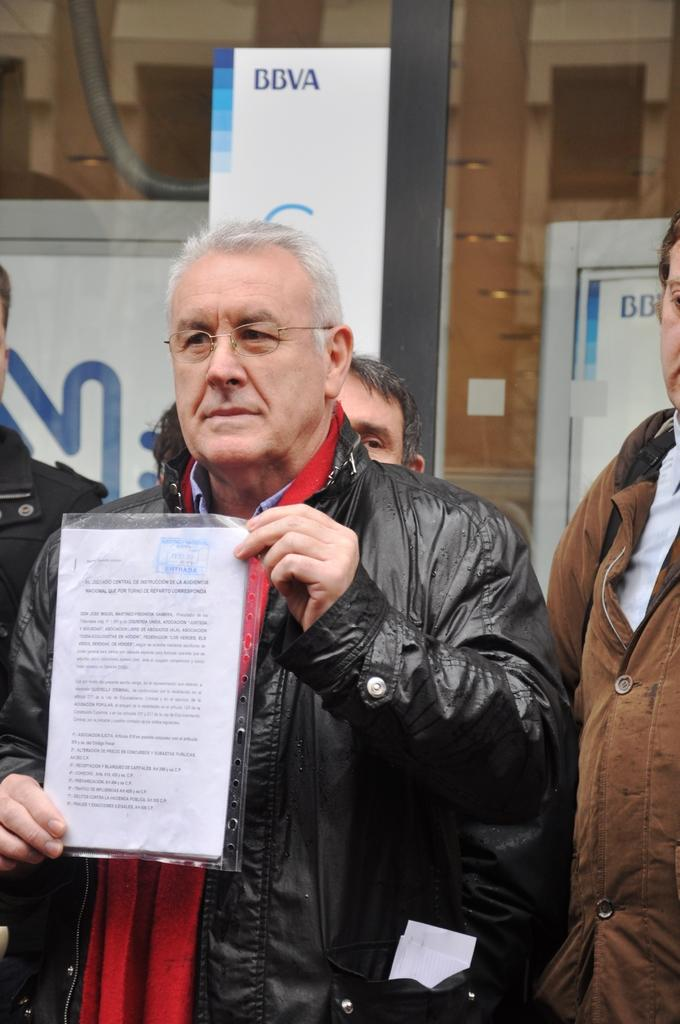What is the man in the image wearing on his face? The man is wearing spectacles in the image. What type of clothing is the man wearing on his upper body? The man is wearing a jacket and a shirt in the image. What is the man holding in the image? The man is holding a paper in the image. Can you describe the people around the man? There is another man beside him in the image. What can be seen in the background of the image? There are posters, doors, and a pole in the background of the image. How many boats are visible in the image? There are no boats present in the image. What type of songs can be heard in the background of the image? There is no audio information provided in the image, so it is not possible to determine what songs might be heard. 